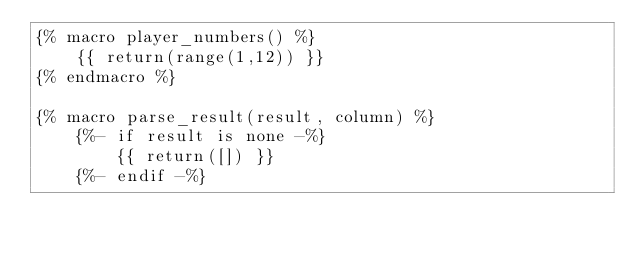<code> <loc_0><loc_0><loc_500><loc_500><_SQL_>{% macro player_numbers() %}
    {{ return(range(1,12)) }}
{% endmacro %}

{% macro parse_result(result, column) %}
    {%- if result is none -%}
        {{ return([]) }}
    {%- endif -%}
</code> 